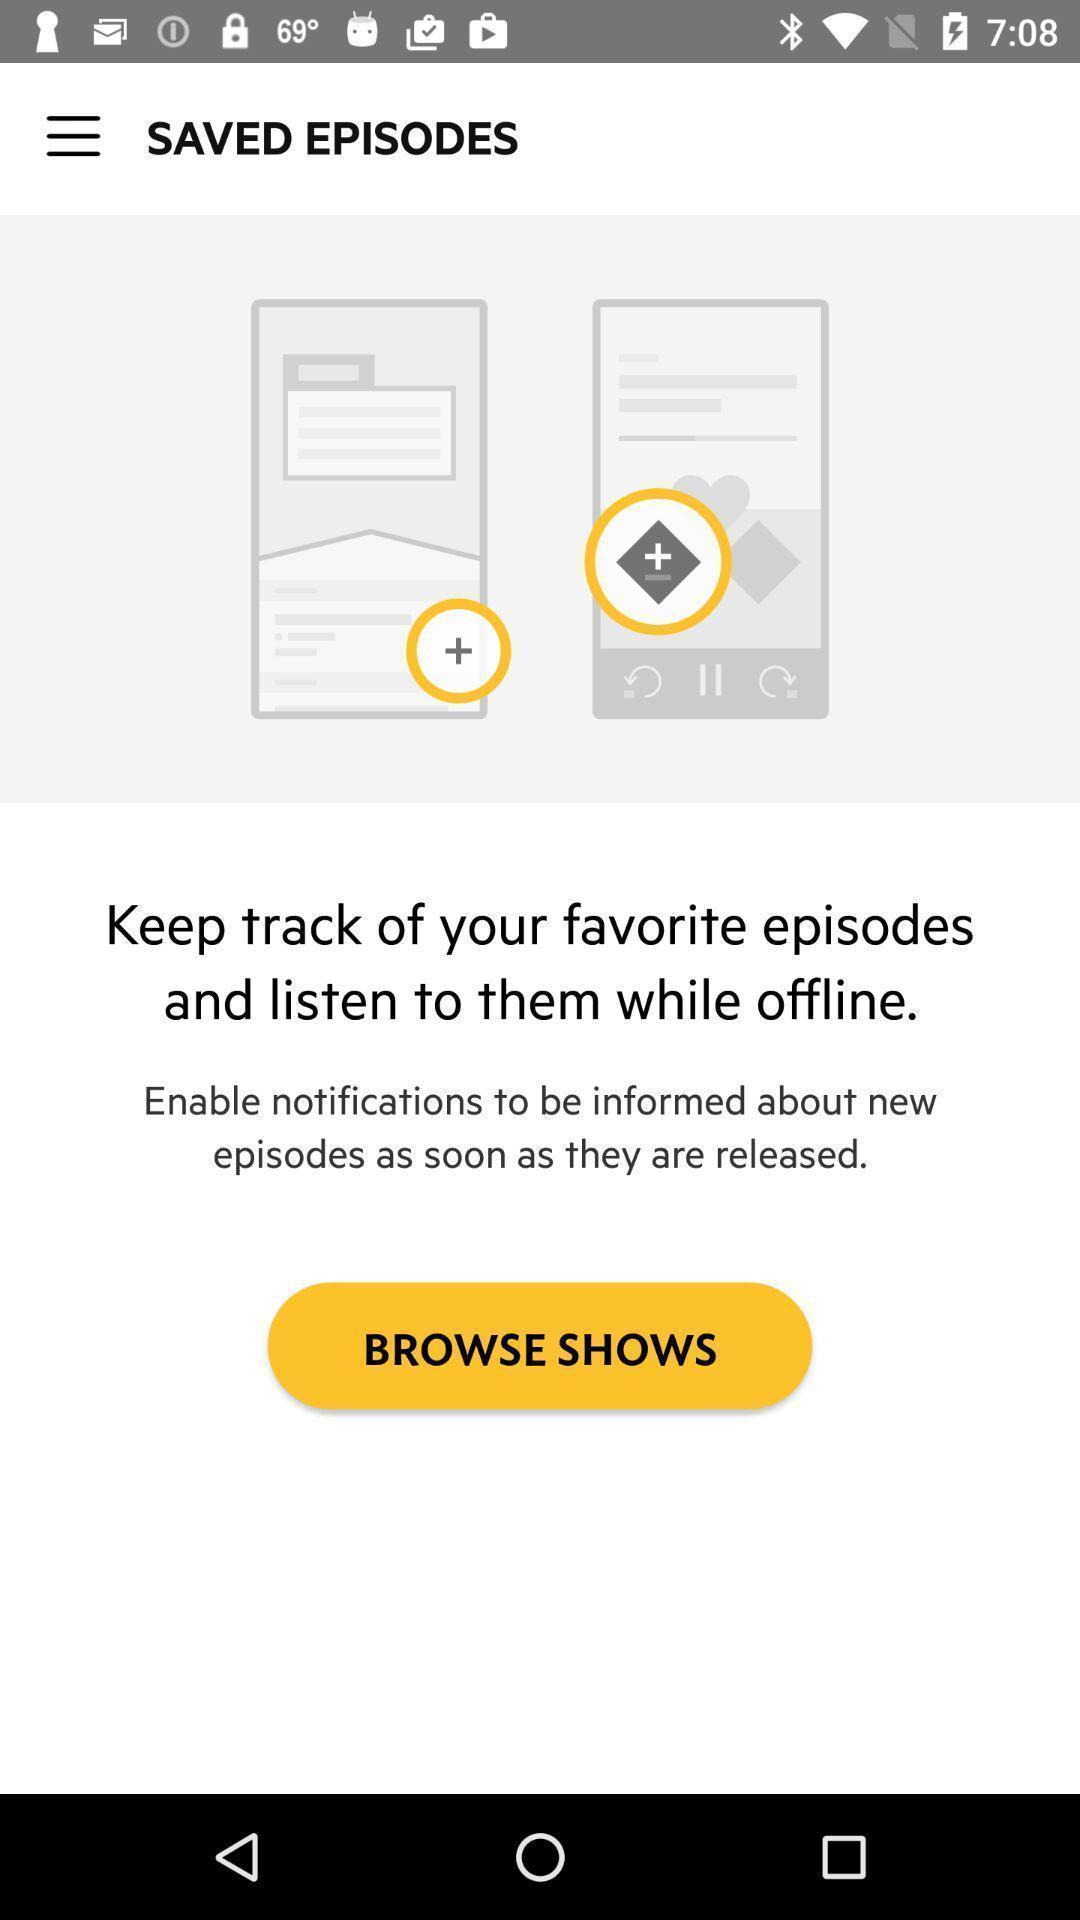Provide a detailed account of this screenshot. Saved episodes page of an online streaming movies app. 